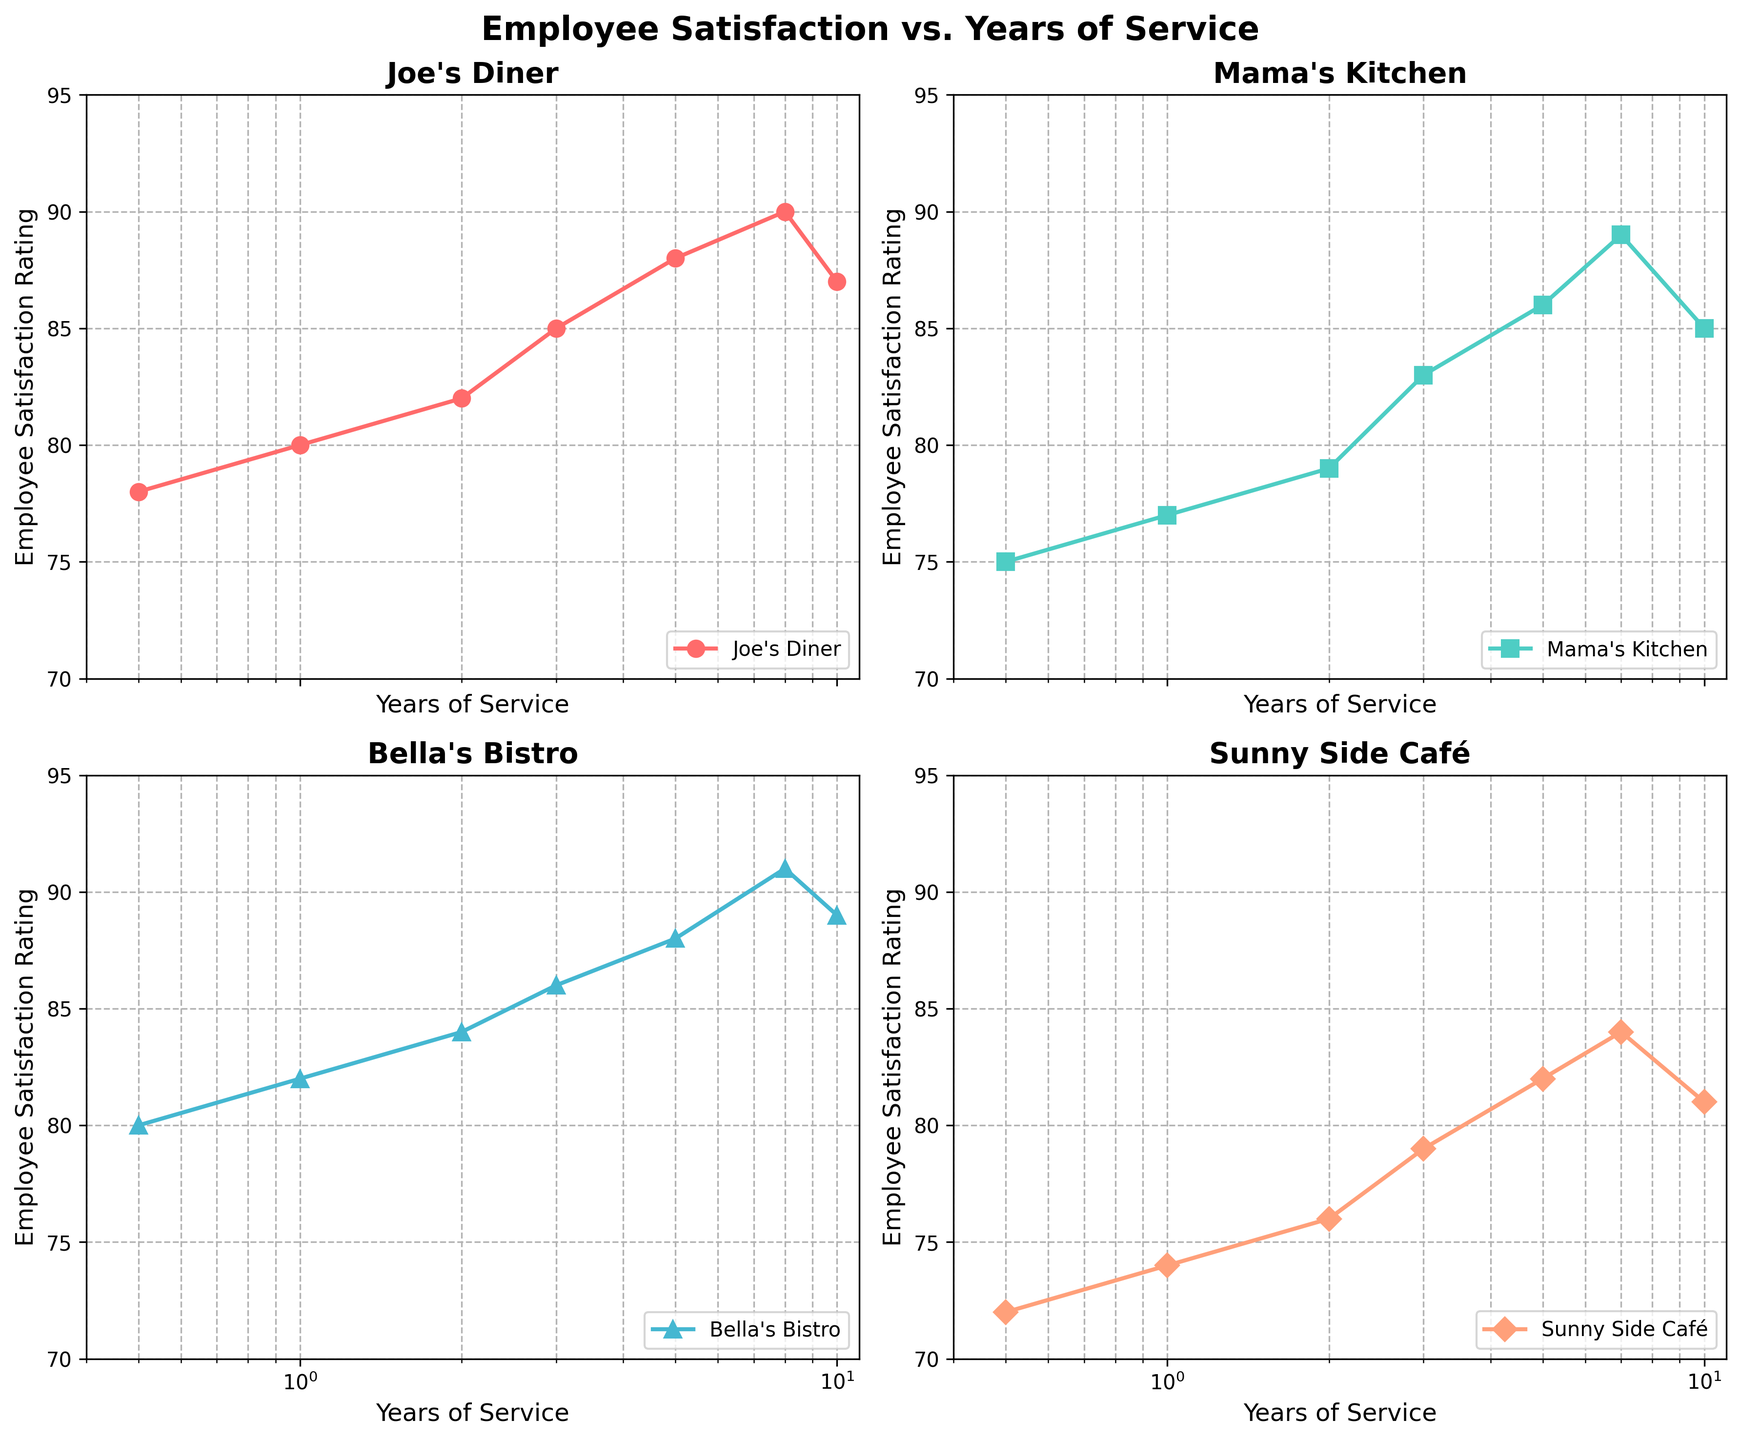What is the title of the figure? The title of the figure is shown at the top of the plot.
Answer: Employee Satisfaction vs. Years of Service Which restaurant has the highest satisfaction rating at 5 years of service? At 5 years of service, you need to look at the fifth data point from the left on each subplot. Compare the values: Joe's Diner (88), Mama's Kitchen (86), Bella's Bistro (88), Sunny Side Café (82). The highest rating is 88, seen in Joe's Diner and Bella's Bistro.
Answer: Joe's Diner and Bella's Bistro How does the satisfaction rating change from 3 to 5 years of service at Mama's Kitchen? Identify the points at 3 and 5 years on Mama's Kitchen's subplot. Satisfaction increases from 83 to 86, a difference of 3 points.
Answer: It increases by 3 points Which restaurant has the lowest initial satisfaction rating at 0.5 years of service? At 0.5 years, you look at the first data points in each subplot: Joe's Diner (78), Mama's Kitchen (75), Bella's Bistro (80), Sunny Side Café (72). The lowest rating is 72 at Sunny Side Café.
Answer: Sunny Side Café What's the average employee satisfaction between 0.5 and 3 years of service at Bella's Bistro? Sum the satisfaction ratings at 0.5, 1, 2, and 3 years: (80 + 82 + 84 + 86) = 332. Divide by the number of points (4) to get the average.
Answer: 83 How does satisfaction rating change at Joe's Diner from 3 to 10 years of service? Check the values at 3 and 10 years: (85 and 87). Subtract the rating at 3 years from that at 10 years to find the change.
Answer: It increases by 2 points Which restaurant shows the biggest gain in satisfaction from 0.5 to 2 years of service? Calculate the gain for each restaurant:
- Joe's Diner: 82 - 78 = 4
- Mama's Kitchen: 79 - 75 = 4
- Bella's Bistro: 84 - 80 = 4
- Sunny Side Café: 76 - 72 = 4
All restaurants have the same gain.
Answer: All have the same gain Between Joe's Diner and Sunny Side Café, which restaurant has a higher satisfaction rating at 8 years of service? Compare the satisfaction ratings at 8 years: Joe's Diner (90), Sunny Side Café (84). Joe's Diner has a higher rating.
Answer: Joe's Diner What is the trend of satisfaction ratings over time for Bella's Bistro? Observation suggests that the satisfaction rating generally increases over time, especially noticeable at the log scale. Bella's Bistro ratings go consistently upwards, indicating improvement over the years.
Answer: Increasing trend Which restaurant has the most consistent increase in satisfaction ratings? Look at the smoothness and linearity in the increase in ratings for all restaurants. Bella's Bistro appears to have the most consistent year-over-year increments.
Answer: Bella's Bistro 